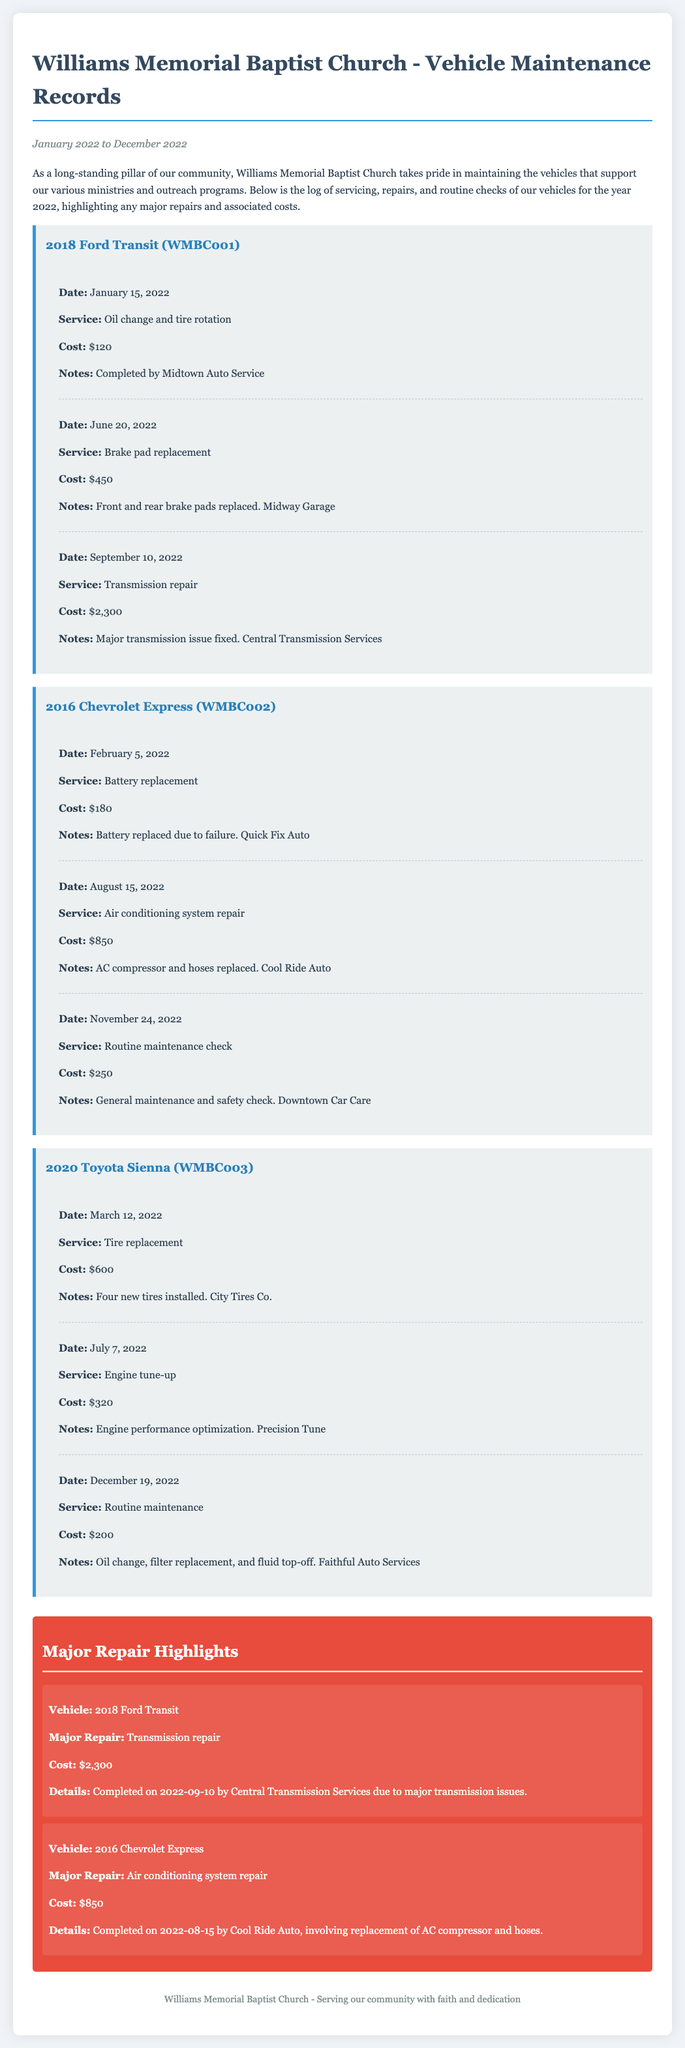What is the total cost of servicing the 2018 Ford Transit? The total cost for the 2018 Ford Transit is calculated by adding all the service costs: $120 + $450 + $2,300 = $2,870.
Answer: $2,870 What major repair was done on the 2016 Chevrolet Express? The major repair performed on the 2016 Chevrolet Express was the air conditioning system repair, which involved replacing the AC compressor and hoses.
Answer: Air conditioning system repair What was the date of the transmission repair for the 2018 Ford Transit? The transmission repair for the 2018 Ford Transit was completed on September 10, 2022.
Answer: September 10, 2022 How much did the battery replacement for the 2016 Chevrolet Express cost? The cost for the battery replacement service on the 2016 Chevrolet Express was $180.
Answer: $180 Which vehicle had a routine maintenance check in November? The vehicle that had a routine maintenance check in November was the 2016 Chevrolet Express.
Answer: 2016 Chevrolet Express What company serviced the air conditioning system repair? The company that performed the air conditioning system repair is Cool Ride Auto.
Answer: Cool Ride Auto What was the cost of the major repair for the 2018 Ford Transit? The cost of the major repair for the 2018 Ford Transit, which was the transmission repair, was $2,300.
Answer: $2,300 What types of services were performed on the 2020 Toyota Sienna? The services performed on the 2020 Toyota Sienna included tire replacement, engine tune-up, and routine maintenance.
Answer: Tire replacement, engine tune-up, routine maintenance How many service items were recorded for the 2018 Ford Transit? There were three service items recorded for the 2018 Ford Transit in the maintenance log.
Answer: Three 